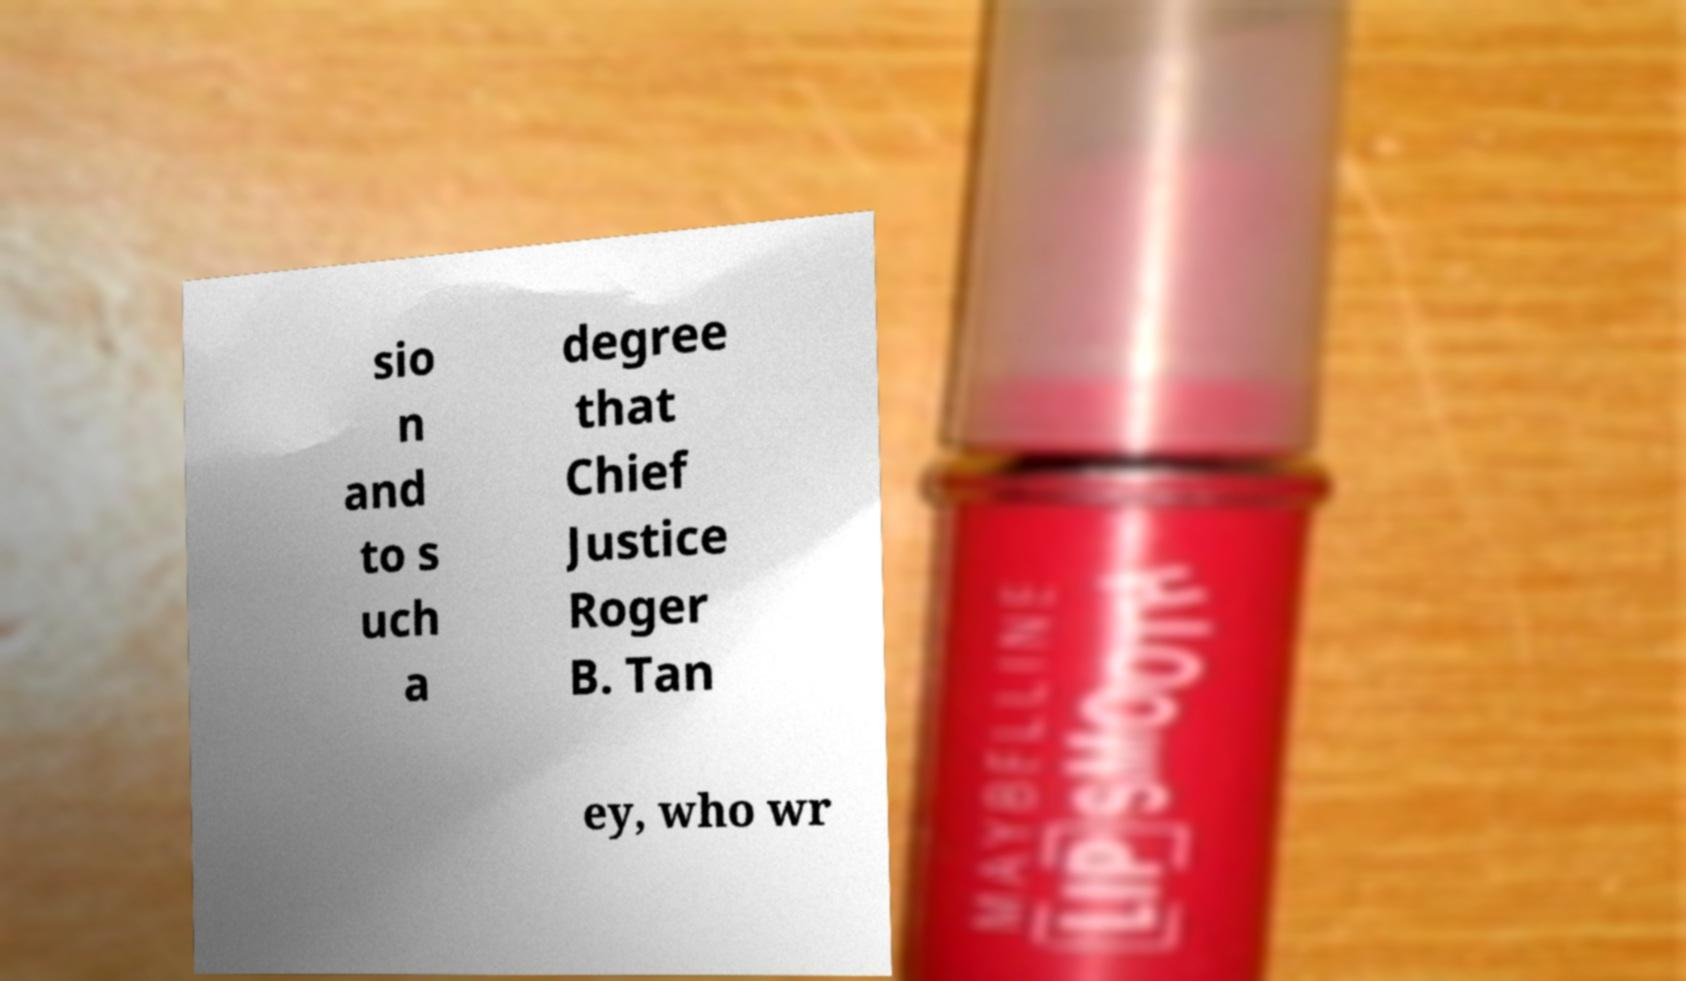For documentation purposes, I need the text within this image transcribed. Could you provide that? sio n and to s uch a degree that Chief Justice Roger B. Tan ey, who wr 